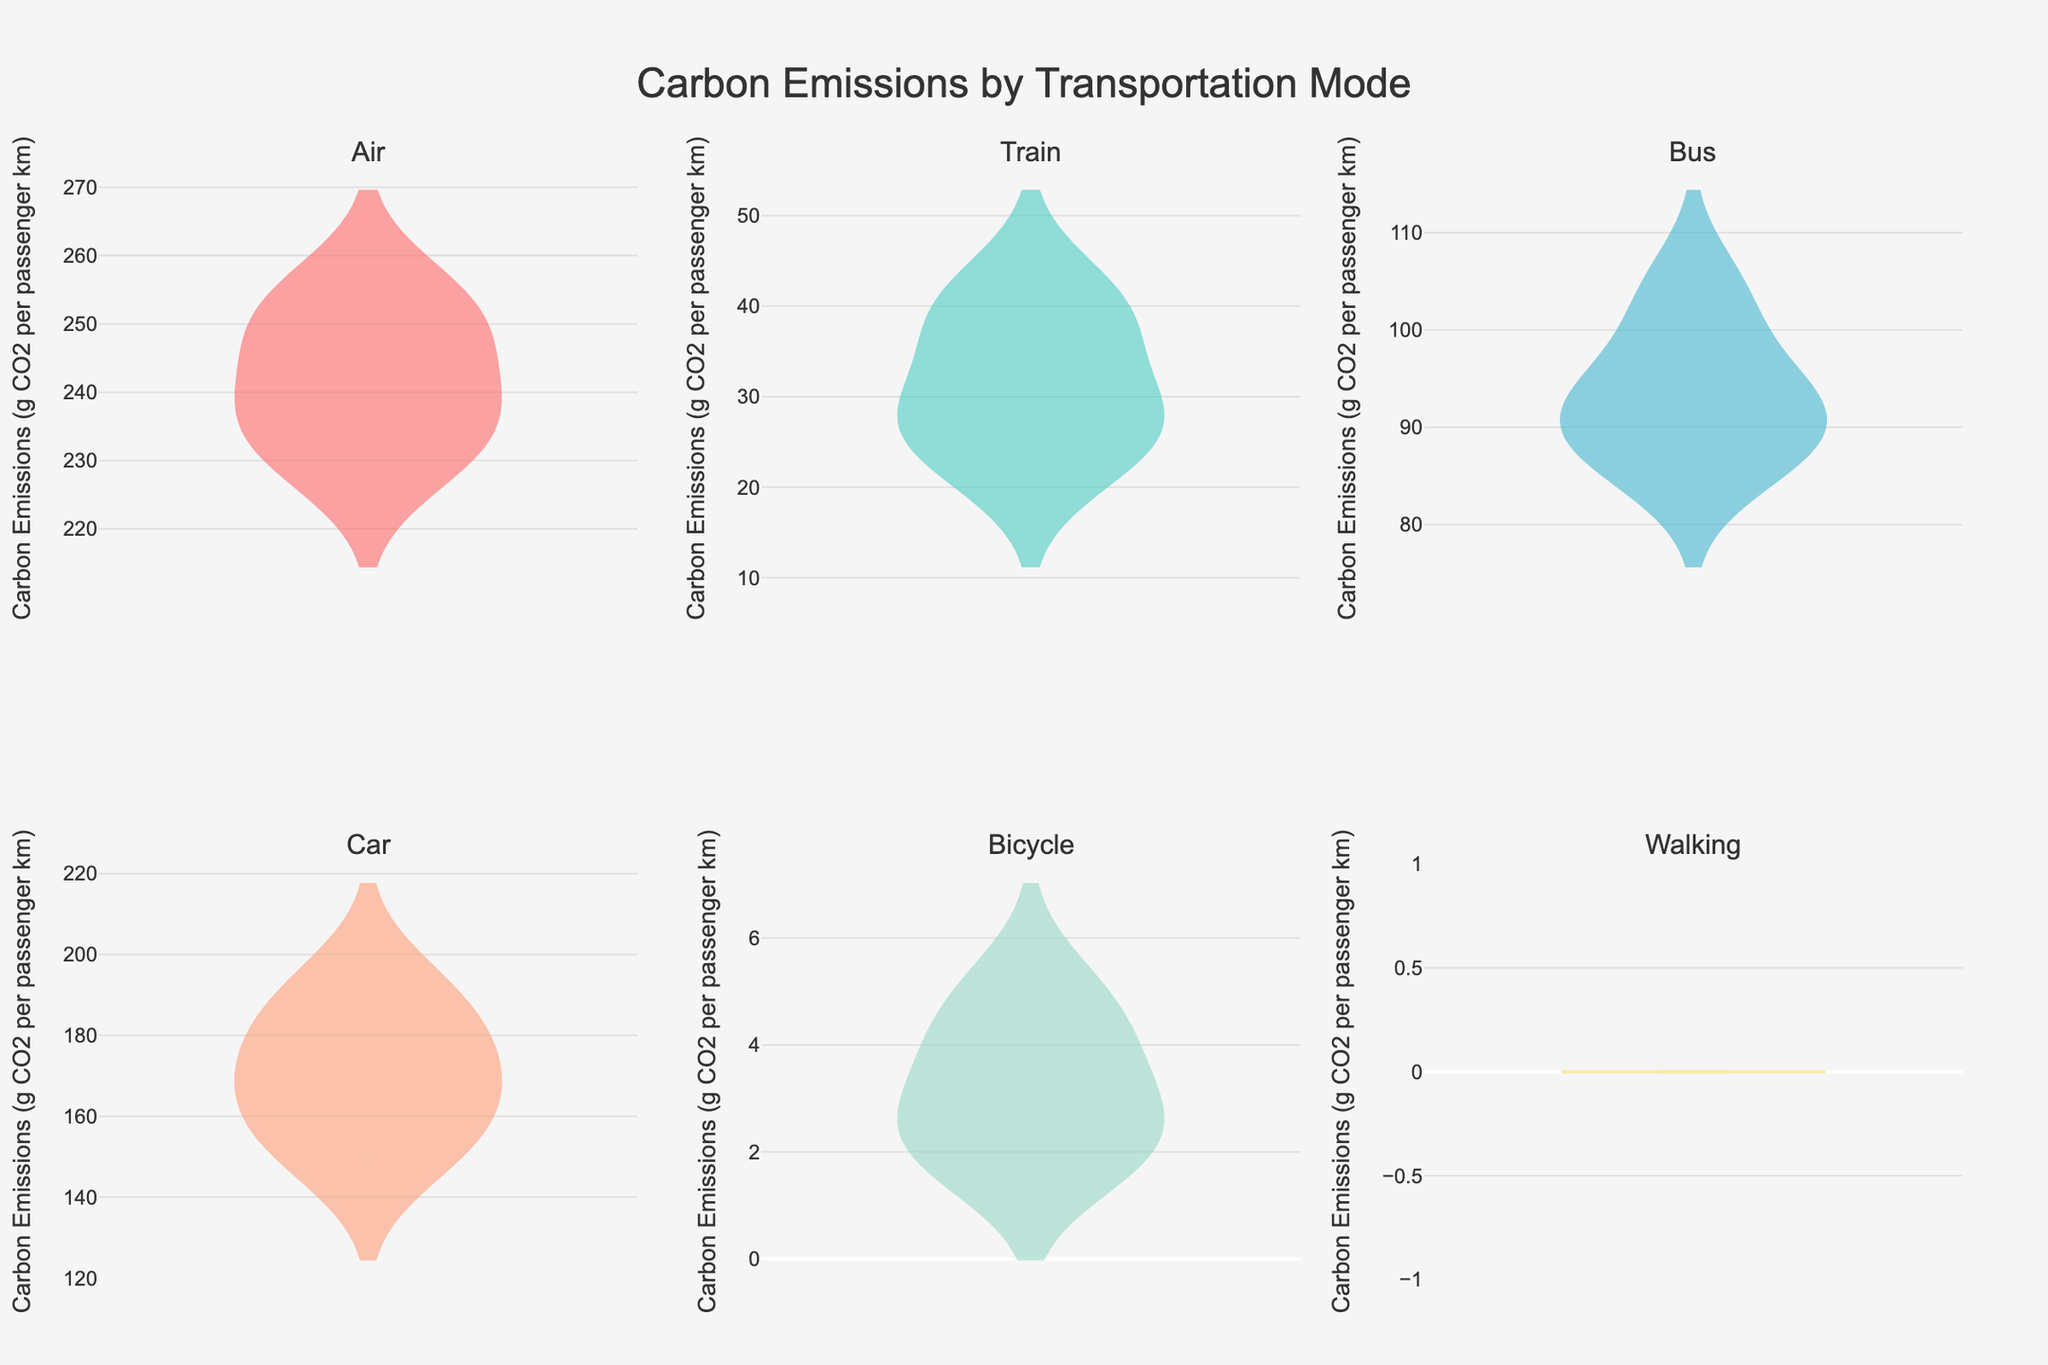What is the title of the figure? The title is usually located at the top of the figure. It summarizes what the figure is about.
Answer: Carbon Emissions by Transportation Mode How many transportation modes are represented in the figure? Count the number of unique subplot titles, each corresponding to a different transportation mode.
Answer: 6 Which transportation mode has the lowest carbon emissions? The mode with the lowest values on its violin chart represents the lowest carbon emissions.
Answer: Walking Which country has the highest carbon emissions per passenger km for the 'Air' mode? Locate the 'Air' mode subplot and identify the highest point along the y-axis.
Answer: US What is the range of carbon emissions for the 'Bus' mode? In the 'Bus' mode subplot, check the range from the minimum to the maximum values on the y-axis.
Answer: 86 - 104 What is the median carbon emission for 'Train' mode and how does it compare to the 'Car' mode? Find the median value indicated by the white dot in the 'Train' and 'Car' subplots. Compare the two values.
Answer: Train: 27, Car: 170. Train median is significantly lower Which transportation mode shows the widest spread of carbon emissions data? Compare the lengths of the violin charts. The mode with the longest chart has the widest spread.
Answer: Air How does the carbon emission for bicycles in the US compare to Germany? Observe the heights of the violin plots for bicycles in both the US and Germany subplots.
Answer: US: 5, Germany: 3. The US has higher emissions What is the difference in median carbon emissions between 'Air' mode and 'Train' mode? Identify the median for both modes and calculate the difference (Air median - Train median).
Answer: Air: ~241, Train: ~27. Difference: ~214 Which mode of transport in Japan has the lowest carbon emissions? Look at the lowest points in the Japan plots for all modes. Identify the mode with the smallest value.
Answer: Walking 